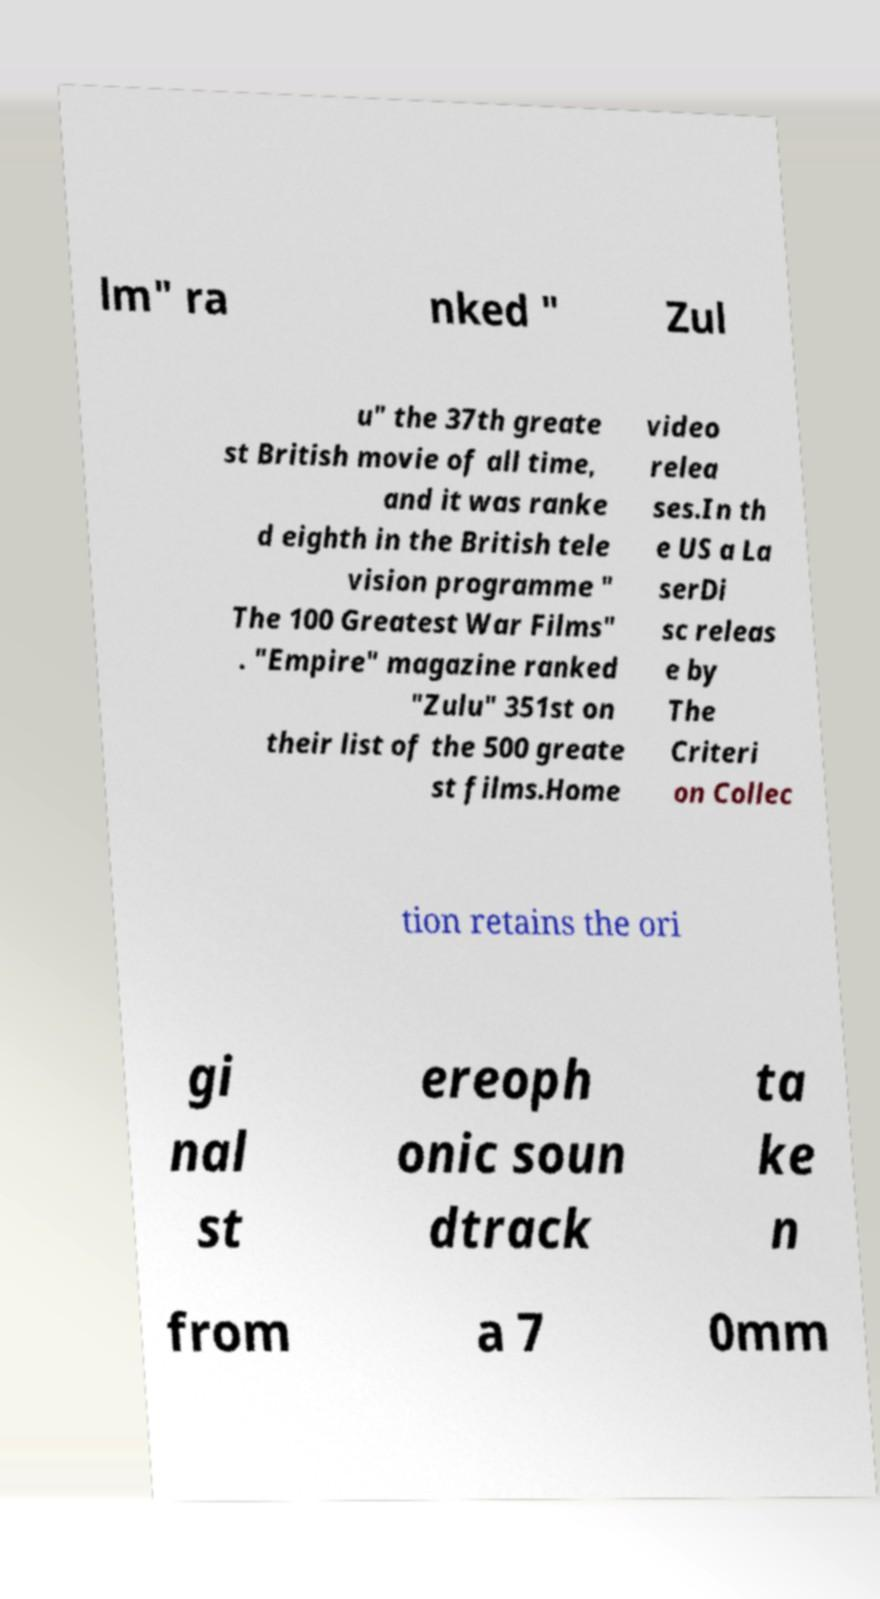Can you read and provide the text displayed in the image?This photo seems to have some interesting text. Can you extract and type it out for me? lm" ra nked " Zul u" the 37th greate st British movie of all time, and it was ranke d eighth in the British tele vision programme " The 100 Greatest War Films" . "Empire" magazine ranked "Zulu" 351st on their list of the 500 greate st films.Home video relea ses.In th e US a La serDi sc releas e by The Criteri on Collec tion retains the ori gi nal st ereoph onic soun dtrack ta ke n from a 7 0mm 